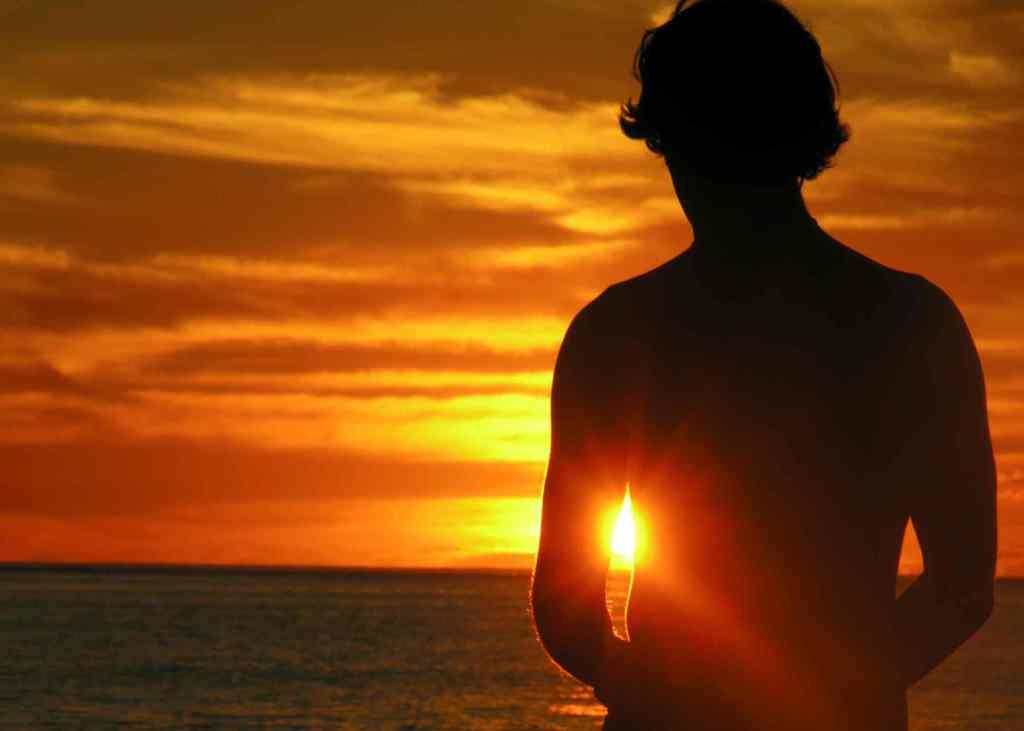Who or what is located in the front of the image? There is a person in the front of the image. What can be seen in the background of the image? There is a cloudy sky, sunlight, and water visible in the background of the image. What type of net is being used by the beginner in the image? There is no beginner or net present in the image. 